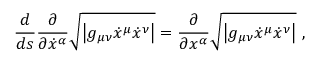<formula> <loc_0><loc_0><loc_500><loc_500>{ \frac { d } { d s } } { \frac { \partial } { \partial { \dot { x } } ^ { \alpha } } } { \sqrt { \left | g _ { \mu \nu } { \dot { x } } ^ { \mu } { \dot { x } } ^ { \nu } \right | } } = { \frac { \partial } { \partial x ^ { \alpha } } } { \sqrt { \left | g _ { \mu \nu } { \dot { x } } ^ { \mu } { \dot { x } } ^ { \nu } \right | } } \ ,</formula> 